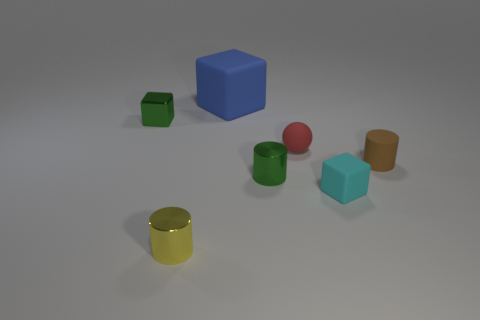Subtract all small green shiny cylinders. How many cylinders are left? 2 Add 3 small red rubber spheres. How many objects exist? 10 Subtract all blue cylinders. Subtract all cyan balls. How many cylinders are left? 3 Subtract all balls. How many objects are left? 6 Subtract 0 red cylinders. How many objects are left? 7 Subtract all big purple metallic cylinders. Subtract all brown cylinders. How many objects are left? 6 Add 7 cyan blocks. How many cyan blocks are left? 8 Add 2 shiny blocks. How many shiny blocks exist? 3 